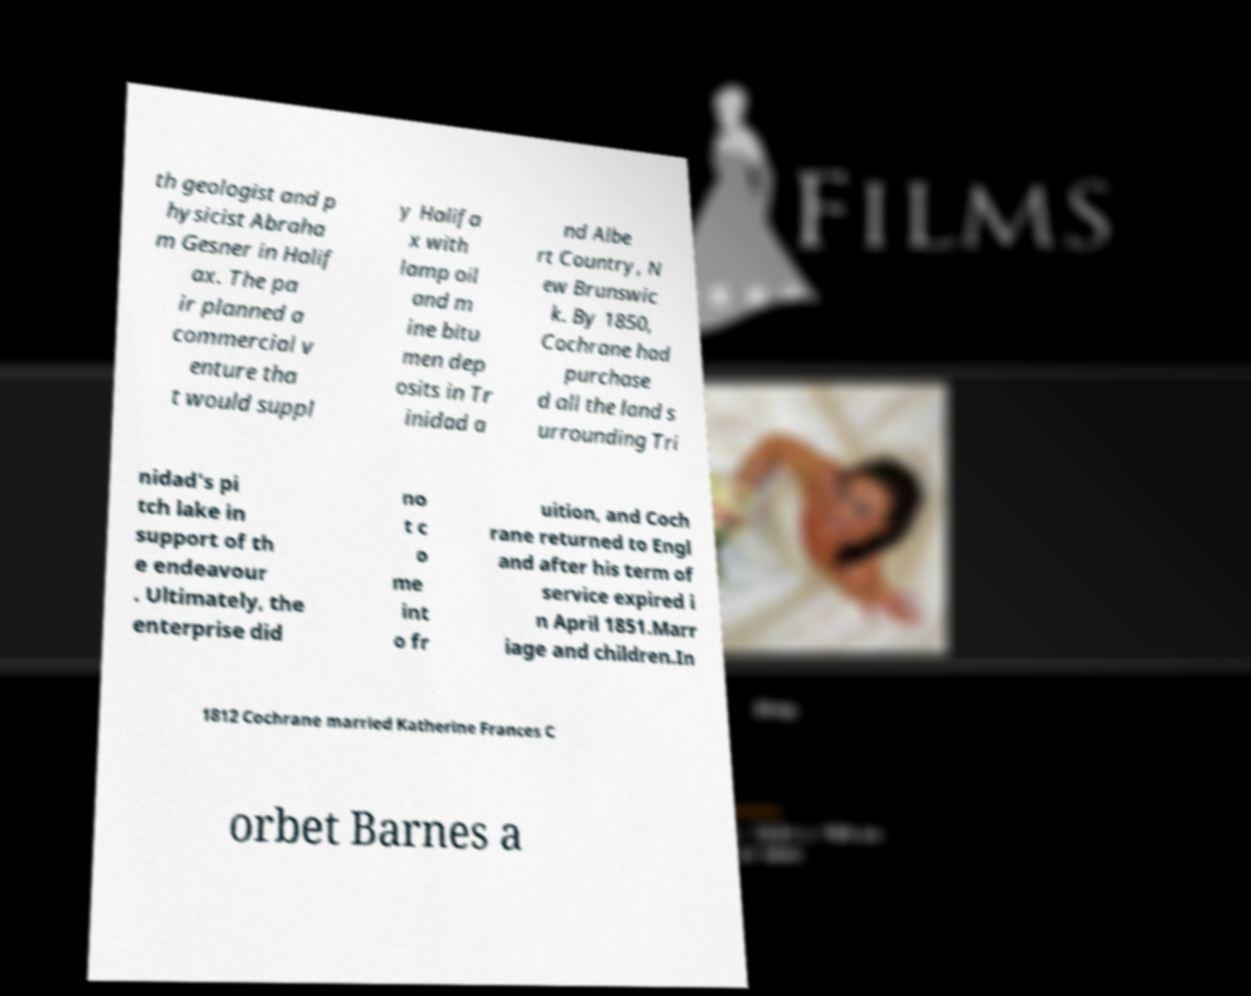Please identify and transcribe the text found in this image. th geologist and p hysicist Abraha m Gesner in Halif ax. The pa ir planned a commercial v enture tha t would suppl y Halifa x with lamp oil and m ine bitu men dep osits in Tr inidad a nd Albe rt Country, N ew Brunswic k. By 1850, Cochrane had purchase d all the land s urrounding Tri nidad's pi tch lake in support of th e endeavour . Ultimately, the enterprise did no t c o me int o fr uition, and Coch rane returned to Engl and after his term of service expired i n April 1851.Marr iage and children.In 1812 Cochrane married Katherine Frances C orbet Barnes a 